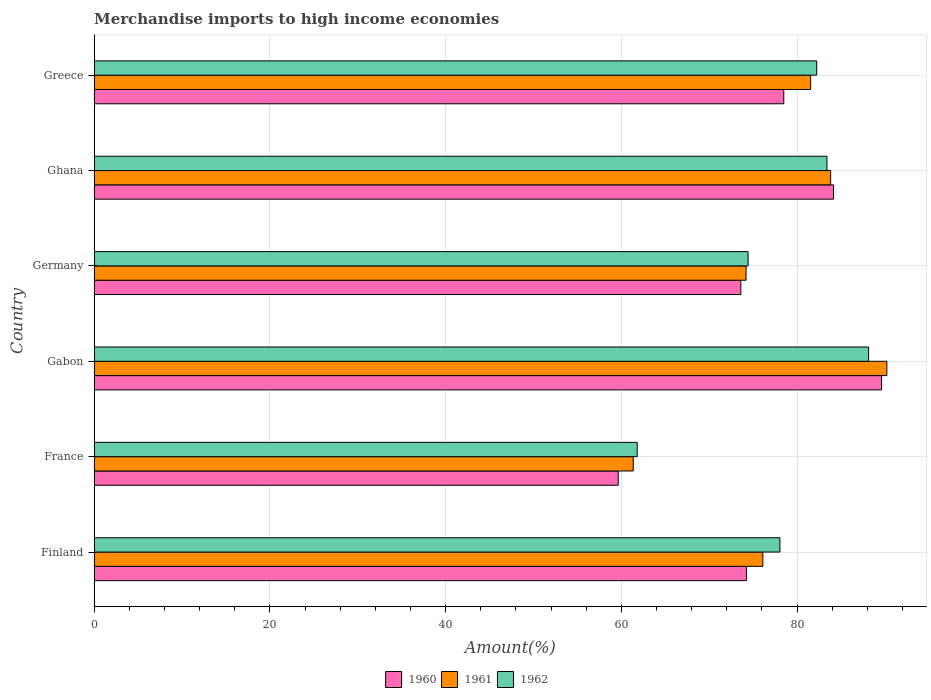How many different coloured bars are there?
Provide a succinct answer. 3. How many groups of bars are there?
Ensure brevity in your answer.  6. How many bars are there on the 6th tick from the top?
Your answer should be very brief. 3. How many bars are there on the 5th tick from the bottom?
Your answer should be compact. 3. In how many cases, is the number of bars for a given country not equal to the number of legend labels?
Keep it short and to the point. 0. What is the percentage of amount earned from merchandise imports in 1962 in Ghana?
Ensure brevity in your answer.  83.4. Across all countries, what is the maximum percentage of amount earned from merchandise imports in 1962?
Provide a succinct answer. 88.14. Across all countries, what is the minimum percentage of amount earned from merchandise imports in 1960?
Provide a succinct answer. 59.65. In which country was the percentage of amount earned from merchandise imports in 1961 maximum?
Keep it short and to the point. Gabon. What is the total percentage of amount earned from merchandise imports in 1961 in the graph?
Provide a short and direct response. 467.26. What is the difference between the percentage of amount earned from merchandise imports in 1961 in France and that in Greece?
Keep it short and to the point. -20.19. What is the difference between the percentage of amount earned from merchandise imports in 1961 in Ghana and the percentage of amount earned from merchandise imports in 1960 in France?
Your answer should be compact. 24.18. What is the average percentage of amount earned from merchandise imports in 1960 per country?
Make the answer very short. 76.63. What is the difference between the percentage of amount earned from merchandise imports in 1962 and percentage of amount earned from merchandise imports in 1960 in Ghana?
Offer a very short reply. -0.74. In how many countries, is the percentage of amount earned from merchandise imports in 1962 greater than 32 %?
Your response must be concise. 6. What is the ratio of the percentage of amount earned from merchandise imports in 1962 in Gabon to that in Ghana?
Ensure brevity in your answer.  1.06. What is the difference between the highest and the second highest percentage of amount earned from merchandise imports in 1960?
Your response must be concise. 5.47. What is the difference between the highest and the lowest percentage of amount earned from merchandise imports in 1961?
Ensure brevity in your answer.  28.87. In how many countries, is the percentage of amount earned from merchandise imports in 1960 greater than the average percentage of amount earned from merchandise imports in 1960 taken over all countries?
Keep it short and to the point. 3. Is the sum of the percentage of amount earned from merchandise imports in 1961 in Ghana and Greece greater than the maximum percentage of amount earned from merchandise imports in 1960 across all countries?
Your answer should be very brief. Yes. What does the 2nd bar from the top in Greece represents?
Keep it short and to the point. 1961. Is it the case that in every country, the sum of the percentage of amount earned from merchandise imports in 1962 and percentage of amount earned from merchandise imports in 1961 is greater than the percentage of amount earned from merchandise imports in 1960?
Keep it short and to the point. Yes. How many bars are there?
Provide a short and direct response. 18. Are all the bars in the graph horizontal?
Offer a very short reply. Yes. Are the values on the major ticks of X-axis written in scientific E-notation?
Your response must be concise. No. Does the graph contain grids?
Provide a succinct answer. Yes. What is the title of the graph?
Your answer should be compact. Merchandise imports to high income economies. Does "2011" appear as one of the legend labels in the graph?
Your answer should be compact. No. What is the label or title of the X-axis?
Make the answer very short. Amount(%). What is the Amount(%) of 1960 in Finland?
Provide a succinct answer. 74.24. What is the Amount(%) in 1961 in Finland?
Your answer should be compact. 76.11. What is the Amount(%) in 1962 in Finland?
Your response must be concise. 78.05. What is the Amount(%) of 1960 in France?
Your answer should be very brief. 59.65. What is the Amount(%) of 1961 in France?
Your response must be concise. 61.36. What is the Amount(%) of 1962 in France?
Give a very brief answer. 61.81. What is the Amount(%) in 1960 in Gabon?
Give a very brief answer. 89.62. What is the Amount(%) of 1961 in Gabon?
Ensure brevity in your answer.  90.22. What is the Amount(%) in 1962 in Gabon?
Your answer should be compact. 88.14. What is the Amount(%) of 1960 in Germany?
Provide a short and direct response. 73.6. What is the Amount(%) in 1961 in Germany?
Give a very brief answer. 74.2. What is the Amount(%) in 1962 in Germany?
Provide a short and direct response. 74.43. What is the Amount(%) of 1960 in Ghana?
Ensure brevity in your answer.  84.15. What is the Amount(%) in 1961 in Ghana?
Your response must be concise. 83.83. What is the Amount(%) in 1962 in Ghana?
Give a very brief answer. 83.4. What is the Amount(%) of 1960 in Greece?
Ensure brevity in your answer.  78.49. What is the Amount(%) in 1961 in Greece?
Your response must be concise. 81.55. What is the Amount(%) of 1962 in Greece?
Give a very brief answer. 82.24. Across all countries, what is the maximum Amount(%) of 1960?
Give a very brief answer. 89.62. Across all countries, what is the maximum Amount(%) of 1961?
Provide a short and direct response. 90.22. Across all countries, what is the maximum Amount(%) of 1962?
Keep it short and to the point. 88.14. Across all countries, what is the minimum Amount(%) of 1960?
Provide a succinct answer. 59.65. Across all countries, what is the minimum Amount(%) in 1961?
Offer a terse response. 61.36. Across all countries, what is the minimum Amount(%) of 1962?
Provide a short and direct response. 61.81. What is the total Amount(%) of 1960 in the graph?
Your response must be concise. 459.75. What is the total Amount(%) in 1961 in the graph?
Your answer should be compact. 467.26. What is the total Amount(%) in 1962 in the graph?
Your answer should be compact. 468.07. What is the difference between the Amount(%) of 1960 in Finland and that in France?
Keep it short and to the point. 14.59. What is the difference between the Amount(%) in 1961 in Finland and that in France?
Your response must be concise. 14.75. What is the difference between the Amount(%) in 1962 in Finland and that in France?
Provide a short and direct response. 16.24. What is the difference between the Amount(%) of 1960 in Finland and that in Gabon?
Offer a very short reply. -15.38. What is the difference between the Amount(%) of 1961 in Finland and that in Gabon?
Offer a terse response. -14.11. What is the difference between the Amount(%) in 1962 in Finland and that in Gabon?
Give a very brief answer. -10.09. What is the difference between the Amount(%) in 1960 in Finland and that in Germany?
Keep it short and to the point. 0.63. What is the difference between the Amount(%) in 1961 in Finland and that in Germany?
Give a very brief answer. 1.91. What is the difference between the Amount(%) of 1962 in Finland and that in Germany?
Keep it short and to the point. 3.62. What is the difference between the Amount(%) of 1960 in Finland and that in Ghana?
Offer a very short reply. -9.91. What is the difference between the Amount(%) in 1961 in Finland and that in Ghana?
Your answer should be compact. -7.72. What is the difference between the Amount(%) in 1962 in Finland and that in Ghana?
Provide a succinct answer. -5.35. What is the difference between the Amount(%) in 1960 in Finland and that in Greece?
Offer a very short reply. -4.25. What is the difference between the Amount(%) of 1961 in Finland and that in Greece?
Your response must be concise. -5.44. What is the difference between the Amount(%) in 1962 in Finland and that in Greece?
Make the answer very short. -4.19. What is the difference between the Amount(%) in 1960 in France and that in Gabon?
Offer a very short reply. -29.98. What is the difference between the Amount(%) of 1961 in France and that in Gabon?
Keep it short and to the point. -28.87. What is the difference between the Amount(%) of 1962 in France and that in Gabon?
Ensure brevity in your answer.  -26.34. What is the difference between the Amount(%) of 1960 in France and that in Germany?
Give a very brief answer. -13.96. What is the difference between the Amount(%) in 1961 in France and that in Germany?
Provide a short and direct response. -12.84. What is the difference between the Amount(%) of 1962 in France and that in Germany?
Offer a very short reply. -12.62. What is the difference between the Amount(%) of 1960 in France and that in Ghana?
Ensure brevity in your answer.  -24.5. What is the difference between the Amount(%) in 1961 in France and that in Ghana?
Your answer should be very brief. -22.47. What is the difference between the Amount(%) in 1962 in France and that in Ghana?
Ensure brevity in your answer.  -21.6. What is the difference between the Amount(%) in 1960 in France and that in Greece?
Make the answer very short. -18.84. What is the difference between the Amount(%) in 1961 in France and that in Greece?
Offer a very short reply. -20.19. What is the difference between the Amount(%) in 1962 in France and that in Greece?
Your response must be concise. -20.43. What is the difference between the Amount(%) of 1960 in Gabon and that in Germany?
Offer a very short reply. 16.02. What is the difference between the Amount(%) of 1961 in Gabon and that in Germany?
Make the answer very short. 16.03. What is the difference between the Amount(%) of 1962 in Gabon and that in Germany?
Keep it short and to the point. 13.72. What is the difference between the Amount(%) of 1960 in Gabon and that in Ghana?
Keep it short and to the point. 5.47. What is the difference between the Amount(%) of 1961 in Gabon and that in Ghana?
Provide a succinct answer. 6.4. What is the difference between the Amount(%) of 1962 in Gabon and that in Ghana?
Provide a short and direct response. 4.74. What is the difference between the Amount(%) of 1960 in Gabon and that in Greece?
Provide a succinct answer. 11.13. What is the difference between the Amount(%) in 1961 in Gabon and that in Greece?
Ensure brevity in your answer.  8.68. What is the difference between the Amount(%) of 1962 in Gabon and that in Greece?
Offer a terse response. 5.91. What is the difference between the Amount(%) of 1960 in Germany and that in Ghana?
Your answer should be very brief. -10.54. What is the difference between the Amount(%) in 1961 in Germany and that in Ghana?
Offer a terse response. -9.63. What is the difference between the Amount(%) in 1962 in Germany and that in Ghana?
Your answer should be very brief. -8.98. What is the difference between the Amount(%) of 1960 in Germany and that in Greece?
Ensure brevity in your answer.  -4.89. What is the difference between the Amount(%) of 1961 in Germany and that in Greece?
Your response must be concise. -7.35. What is the difference between the Amount(%) in 1962 in Germany and that in Greece?
Provide a succinct answer. -7.81. What is the difference between the Amount(%) of 1960 in Ghana and that in Greece?
Offer a terse response. 5.66. What is the difference between the Amount(%) of 1961 in Ghana and that in Greece?
Ensure brevity in your answer.  2.28. What is the difference between the Amount(%) of 1962 in Ghana and that in Greece?
Your response must be concise. 1.17. What is the difference between the Amount(%) of 1960 in Finland and the Amount(%) of 1961 in France?
Provide a short and direct response. 12.88. What is the difference between the Amount(%) in 1960 in Finland and the Amount(%) in 1962 in France?
Offer a terse response. 12.43. What is the difference between the Amount(%) of 1961 in Finland and the Amount(%) of 1962 in France?
Your answer should be compact. 14.3. What is the difference between the Amount(%) in 1960 in Finland and the Amount(%) in 1961 in Gabon?
Offer a very short reply. -15.98. What is the difference between the Amount(%) of 1960 in Finland and the Amount(%) of 1962 in Gabon?
Your answer should be compact. -13.91. What is the difference between the Amount(%) of 1961 in Finland and the Amount(%) of 1962 in Gabon?
Your response must be concise. -12.03. What is the difference between the Amount(%) in 1960 in Finland and the Amount(%) in 1961 in Germany?
Provide a short and direct response. 0.04. What is the difference between the Amount(%) of 1960 in Finland and the Amount(%) of 1962 in Germany?
Ensure brevity in your answer.  -0.19. What is the difference between the Amount(%) in 1961 in Finland and the Amount(%) in 1962 in Germany?
Provide a short and direct response. 1.68. What is the difference between the Amount(%) of 1960 in Finland and the Amount(%) of 1961 in Ghana?
Ensure brevity in your answer.  -9.59. What is the difference between the Amount(%) of 1960 in Finland and the Amount(%) of 1962 in Ghana?
Offer a very short reply. -9.16. What is the difference between the Amount(%) of 1961 in Finland and the Amount(%) of 1962 in Ghana?
Provide a succinct answer. -7.29. What is the difference between the Amount(%) of 1960 in Finland and the Amount(%) of 1961 in Greece?
Provide a short and direct response. -7.31. What is the difference between the Amount(%) in 1960 in Finland and the Amount(%) in 1962 in Greece?
Provide a succinct answer. -8. What is the difference between the Amount(%) of 1961 in Finland and the Amount(%) of 1962 in Greece?
Offer a terse response. -6.13. What is the difference between the Amount(%) of 1960 in France and the Amount(%) of 1961 in Gabon?
Offer a very short reply. -30.58. What is the difference between the Amount(%) of 1960 in France and the Amount(%) of 1962 in Gabon?
Make the answer very short. -28.5. What is the difference between the Amount(%) of 1961 in France and the Amount(%) of 1962 in Gabon?
Provide a succinct answer. -26.79. What is the difference between the Amount(%) of 1960 in France and the Amount(%) of 1961 in Germany?
Ensure brevity in your answer.  -14.55. What is the difference between the Amount(%) of 1960 in France and the Amount(%) of 1962 in Germany?
Offer a terse response. -14.78. What is the difference between the Amount(%) in 1961 in France and the Amount(%) in 1962 in Germany?
Provide a short and direct response. -13.07. What is the difference between the Amount(%) of 1960 in France and the Amount(%) of 1961 in Ghana?
Ensure brevity in your answer.  -24.18. What is the difference between the Amount(%) of 1960 in France and the Amount(%) of 1962 in Ghana?
Your response must be concise. -23.76. What is the difference between the Amount(%) of 1961 in France and the Amount(%) of 1962 in Ghana?
Keep it short and to the point. -22.05. What is the difference between the Amount(%) in 1960 in France and the Amount(%) in 1961 in Greece?
Keep it short and to the point. -21.9. What is the difference between the Amount(%) in 1960 in France and the Amount(%) in 1962 in Greece?
Your response must be concise. -22.59. What is the difference between the Amount(%) of 1961 in France and the Amount(%) of 1962 in Greece?
Provide a succinct answer. -20.88. What is the difference between the Amount(%) of 1960 in Gabon and the Amount(%) of 1961 in Germany?
Ensure brevity in your answer.  15.43. What is the difference between the Amount(%) of 1960 in Gabon and the Amount(%) of 1962 in Germany?
Your answer should be very brief. 15.19. What is the difference between the Amount(%) in 1961 in Gabon and the Amount(%) in 1962 in Germany?
Give a very brief answer. 15.8. What is the difference between the Amount(%) of 1960 in Gabon and the Amount(%) of 1961 in Ghana?
Offer a very short reply. 5.8. What is the difference between the Amount(%) in 1960 in Gabon and the Amount(%) in 1962 in Ghana?
Keep it short and to the point. 6.22. What is the difference between the Amount(%) in 1961 in Gabon and the Amount(%) in 1962 in Ghana?
Your answer should be very brief. 6.82. What is the difference between the Amount(%) of 1960 in Gabon and the Amount(%) of 1961 in Greece?
Provide a short and direct response. 8.07. What is the difference between the Amount(%) in 1960 in Gabon and the Amount(%) in 1962 in Greece?
Offer a terse response. 7.39. What is the difference between the Amount(%) of 1961 in Gabon and the Amount(%) of 1962 in Greece?
Offer a terse response. 7.99. What is the difference between the Amount(%) of 1960 in Germany and the Amount(%) of 1961 in Ghana?
Provide a succinct answer. -10.22. What is the difference between the Amount(%) in 1960 in Germany and the Amount(%) in 1962 in Ghana?
Offer a terse response. -9.8. What is the difference between the Amount(%) of 1961 in Germany and the Amount(%) of 1962 in Ghana?
Give a very brief answer. -9.21. What is the difference between the Amount(%) of 1960 in Germany and the Amount(%) of 1961 in Greece?
Ensure brevity in your answer.  -7.94. What is the difference between the Amount(%) of 1960 in Germany and the Amount(%) of 1962 in Greece?
Your response must be concise. -8.63. What is the difference between the Amount(%) of 1961 in Germany and the Amount(%) of 1962 in Greece?
Your answer should be compact. -8.04. What is the difference between the Amount(%) of 1960 in Ghana and the Amount(%) of 1961 in Greece?
Provide a succinct answer. 2.6. What is the difference between the Amount(%) of 1960 in Ghana and the Amount(%) of 1962 in Greece?
Your answer should be compact. 1.91. What is the difference between the Amount(%) of 1961 in Ghana and the Amount(%) of 1962 in Greece?
Offer a very short reply. 1.59. What is the average Amount(%) of 1960 per country?
Your answer should be very brief. 76.62. What is the average Amount(%) in 1961 per country?
Offer a very short reply. 77.88. What is the average Amount(%) of 1962 per country?
Offer a terse response. 78.01. What is the difference between the Amount(%) in 1960 and Amount(%) in 1961 in Finland?
Your answer should be compact. -1.87. What is the difference between the Amount(%) of 1960 and Amount(%) of 1962 in Finland?
Provide a short and direct response. -3.81. What is the difference between the Amount(%) in 1961 and Amount(%) in 1962 in Finland?
Keep it short and to the point. -1.94. What is the difference between the Amount(%) in 1960 and Amount(%) in 1961 in France?
Offer a very short reply. -1.71. What is the difference between the Amount(%) in 1960 and Amount(%) in 1962 in France?
Offer a very short reply. -2.16. What is the difference between the Amount(%) of 1961 and Amount(%) of 1962 in France?
Make the answer very short. -0.45. What is the difference between the Amount(%) in 1960 and Amount(%) in 1961 in Gabon?
Offer a terse response. -0.6. What is the difference between the Amount(%) of 1960 and Amount(%) of 1962 in Gabon?
Offer a very short reply. 1.48. What is the difference between the Amount(%) in 1961 and Amount(%) in 1962 in Gabon?
Offer a terse response. 2.08. What is the difference between the Amount(%) of 1960 and Amount(%) of 1961 in Germany?
Provide a succinct answer. -0.59. What is the difference between the Amount(%) of 1960 and Amount(%) of 1962 in Germany?
Offer a very short reply. -0.82. What is the difference between the Amount(%) of 1961 and Amount(%) of 1962 in Germany?
Your answer should be compact. -0.23. What is the difference between the Amount(%) in 1960 and Amount(%) in 1961 in Ghana?
Give a very brief answer. 0.32. What is the difference between the Amount(%) of 1960 and Amount(%) of 1962 in Ghana?
Keep it short and to the point. 0.74. What is the difference between the Amount(%) in 1961 and Amount(%) in 1962 in Ghana?
Give a very brief answer. 0.42. What is the difference between the Amount(%) in 1960 and Amount(%) in 1961 in Greece?
Keep it short and to the point. -3.06. What is the difference between the Amount(%) of 1960 and Amount(%) of 1962 in Greece?
Give a very brief answer. -3.75. What is the difference between the Amount(%) of 1961 and Amount(%) of 1962 in Greece?
Keep it short and to the point. -0.69. What is the ratio of the Amount(%) in 1960 in Finland to that in France?
Provide a succinct answer. 1.24. What is the ratio of the Amount(%) in 1961 in Finland to that in France?
Provide a short and direct response. 1.24. What is the ratio of the Amount(%) in 1962 in Finland to that in France?
Provide a succinct answer. 1.26. What is the ratio of the Amount(%) of 1960 in Finland to that in Gabon?
Your answer should be compact. 0.83. What is the ratio of the Amount(%) of 1961 in Finland to that in Gabon?
Provide a succinct answer. 0.84. What is the ratio of the Amount(%) in 1962 in Finland to that in Gabon?
Your answer should be very brief. 0.89. What is the ratio of the Amount(%) of 1960 in Finland to that in Germany?
Your answer should be compact. 1.01. What is the ratio of the Amount(%) in 1961 in Finland to that in Germany?
Provide a succinct answer. 1.03. What is the ratio of the Amount(%) in 1962 in Finland to that in Germany?
Give a very brief answer. 1.05. What is the ratio of the Amount(%) in 1960 in Finland to that in Ghana?
Your answer should be very brief. 0.88. What is the ratio of the Amount(%) of 1961 in Finland to that in Ghana?
Your answer should be very brief. 0.91. What is the ratio of the Amount(%) of 1962 in Finland to that in Ghana?
Provide a short and direct response. 0.94. What is the ratio of the Amount(%) in 1960 in Finland to that in Greece?
Keep it short and to the point. 0.95. What is the ratio of the Amount(%) of 1961 in Finland to that in Greece?
Keep it short and to the point. 0.93. What is the ratio of the Amount(%) in 1962 in Finland to that in Greece?
Make the answer very short. 0.95. What is the ratio of the Amount(%) of 1960 in France to that in Gabon?
Give a very brief answer. 0.67. What is the ratio of the Amount(%) of 1961 in France to that in Gabon?
Your response must be concise. 0.68. What is the ratio of the Amount(%) of 1962 in France to that in Gabon?
Provide a succinct answer. 0.7. What is the ratio of the Amount(%) in 1960 in France to that in Germany?
Keep it short and to the point. 0.81. What is the ratio of the Amount(%) in 1961 in France to that in Germany?
Keep it short and to the point. 0.83. What is the ratio of the Amount(%) of 1962 in France to that in Germany?
Offer a terse response. 0.83. What is the ratio of the Amount(%) in 1960 in France to that in Ghana?
Your answer should be very brief. 0.71. What is the ratio of the Amount(%) in 1961 in France to that in Ghana?
Keep it short and to the point. 0.73. What is the ratio of the Amount(%) of 1962 in France to that in Ghana?
Your response must be concise. 0.74. What is the ratio of the Amount(%) in 1960 in France to that in Greece?
Offer a very short reply. 0.76. What is the ratio of the Amount(%) of 1961 in France to that in Greece?
Ensure brevity in your answer.  0.75. What is the ratio of the Amount(%) in 1962 in France to that in Greece?
Offer a very short reply. 0.75. What is the ratio of the Amount(%) in 1960 in Gabon to that in Germany?
Ensure brevity in your answer.  1.22. What is the ratio of the Amount(%) in 1961 in Gabon to that in Germany?
Your response must be concise. 1.22. What is the ratio of the Amount(%) in 1962 in Gabon to that in Germany?
Ensure brevity in your answer.  1.18. What is the ratio of the Amount(%) in 1960 in Gabon to that in Ghana?
Keep it short and to the point. 1.07. What is the ratio of the Amount(%) of 1961 in Gabon to that in Ghana?
Your answer should be very brief. 1.08. What is the ratio of the Amount(%) of 1962 in Gabon to that in Ghana?
Your answer should be very brief. 1.06. What is the ratio of the Amount(%) in 1960 in Gabon to that in Greece?
Provide a short and direct response. 1.14. What is the ratio of the Amount(%) of 1961 in Gabon to that in Greece?
Provide a succinct answer. 1.11. What is the ratio of the Amount(%) in 1962 in Gabon to that in Greece?
Provide a short and direct response. 1.07. What is the ratio of the Amount(%) of 1960 in Germany to that in Ghana?
Make the answer very short. 0.87. What is the ratio of the Amount(%) in 1961 in Germany to that in Ghana?
Ensure brevity in your answer.  0.89. What is the ratio of the Amount(%) of 1962 in Germany to that in Ghana?
Make the answer very short. 0.89. What is the ratio of the Amount(%) in 1960 in Germany to that in Greece?
Offer a terse response. 0.94. What is the ratio of the Amount(%) of 1961 in Germany to that in Greece?
Make the answer very short. 0.91. What is the ratio of the Amount(%) in 1962 in Germany to that in Greece?
Ensure brevity in your answer.  0.91. What is the ratio of the Amount(%) of 1960 in Ghana to that in Greece?
Ensure brevity in your answer.  1.07. What is the ratio of the Amount(%) of 1961 in Ghana to that in Greece?
Make the answer very short. 1.03. What is the ratio of the Amount(%) in 1962 in Ghana to that in Greece?
Ensure brevity in your answer.  1.01. What is the difference between the highest and the second highest Amount(%) of 1960?
Make the answer very short. 5.47. What is the difference between the highest and the second highest Amount(%) of 1961?
Your answer should be very brief. 6.4. What is the difference between the highest and the second highest Amount(%) of 1962?
Offer a very short reply. 4.74. What is the difference between the highest and the lowest Amount(%) of 1960?
Give a very brief answer. 29.98. What is the difference between the highest and the lowest Amount(%) in 1961?
Provide a succinct answer. 28.87. What is the difference between the highest and the lowest Amount(%) of 1962?
Offer a very short reply. 26.34. 